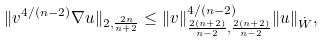<formula> <loc_0><loc_0><loc_500><loc_500>\| v ^ { 4 / ( n - 2 ) } \nabla u \| _ { 2 , \frac { 2 n } { n + 2 } } \leq \| v \| _ { \frac { 2 ( n + 2 ) } { n - 2 } , \frac { 2 ( n + 2 ) } { n - 2 } } ^ { 4 / ( n - 2 ) } \| u \| _ { \dot { W } } ,</formula> 